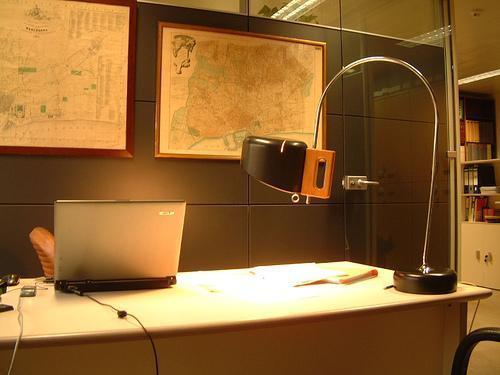How many humans are in the picture?
Give a very brief answer. 0. 